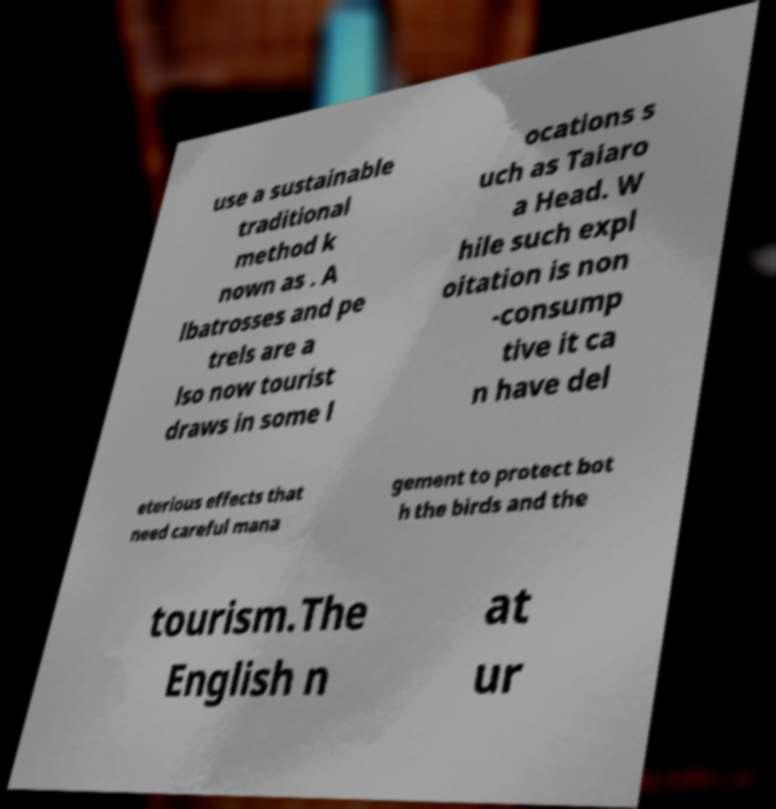I need the written content from this picture converted into text. Can you do that? use a sustainable traditional method k nown as . A lbatrosses and pe trels are a lso now tourist draws in some l ocations s uch as Taiaro a Head. W hile such expl oitation is non -consump tive it ca n have del eterious effects that need careful mana gement to protect bot h the birds and the tourism.The English n at ur 